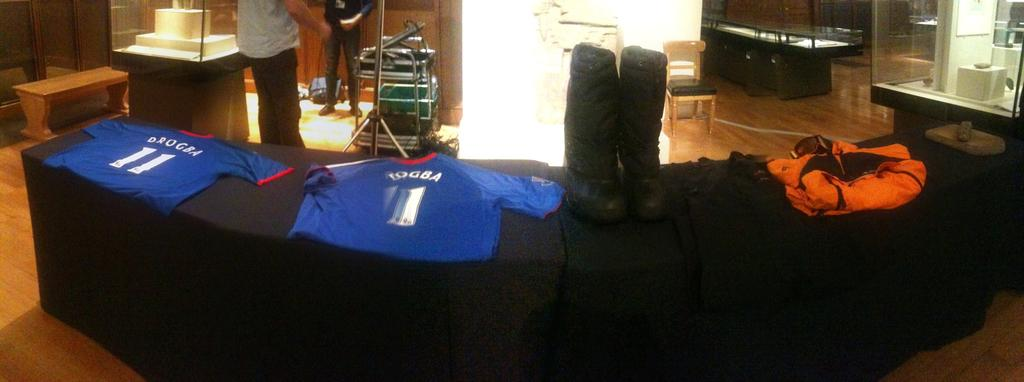How many people are present in the image? There are two people in the image. What are the people wearing in the image? There are two jerseys in the image, which suggests that the people might be wearing them. What type of seating is visible in the image? Chairs and benches are present in the image. What rule is being enforced by the angle of the benches in the image? There is no mention of any rule or angle related to the benches in the image. 